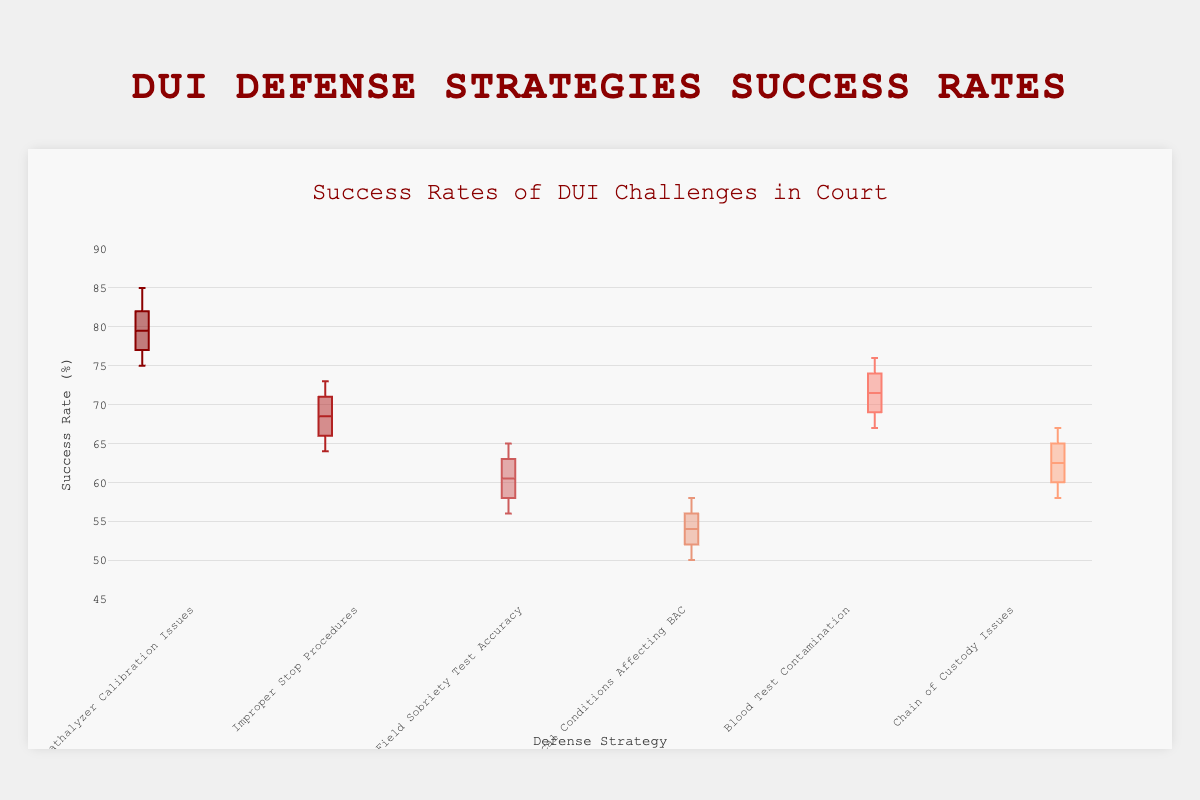What's the title of the chart? The title of the chart is written at the top and is clearly visible.
Answer: Success Rates of DUI Challenges in Court What is the color used for the "Breathalyzer Calibration Issues" defense strategy? The color is part of the legend or the box, making it identifiable.
Answer: Dark Red Which defense strategy has the highest median success rate? To find the median success rate, look for the line inside the box for each strategy and identify the highest one.
Answer: Breathalyzer Calibration Issues What is the success rate range for the "Improper Stop Procedures" defense strategy? The range is determined by the lowest and highest points (whiskers) of the box plot for this strategy.
Answer: 64% to 73% Which defense strategy shows the greatest variability in success rates? The variability can be judged by the size of the interquartile range (height of the box) and the length of the whiskers.
Answer: Field Sobriety Test Accuracy How do the success rates of "Blood Test Contamination" and "Chain of Custody Issues" compare? Compare the medians and ranges (whiskers and boxes) of both strategies side by side.
Answer: Blood Test Contamination has higher success rates What is the range for the "Breathalyzer Calibration Issues" success rates? The range is determined by the lowest and highest points (whiskers) of the box plot for this strategy.
Answer: 75% to 85% Which defense strategy has the lowest minimum success rate? Find the lowest point (bottom whisker) in all box plots to identify the least minimum success rate.
Answer: Medical Conditions Affecting BAC Is the median success rate of "Field Sobriety Test Accuracy" greater than that of "Medical Conditions Affecting BAC"? Compare the median lines inside the boxes for both strategies.
Answer: Yes Which defense strategies have success rates that go above 80%? Identify the boxes and whiskers that extend above the 80% mark on the y-axis.
Answer: Breathalyzer Calibration Issues 